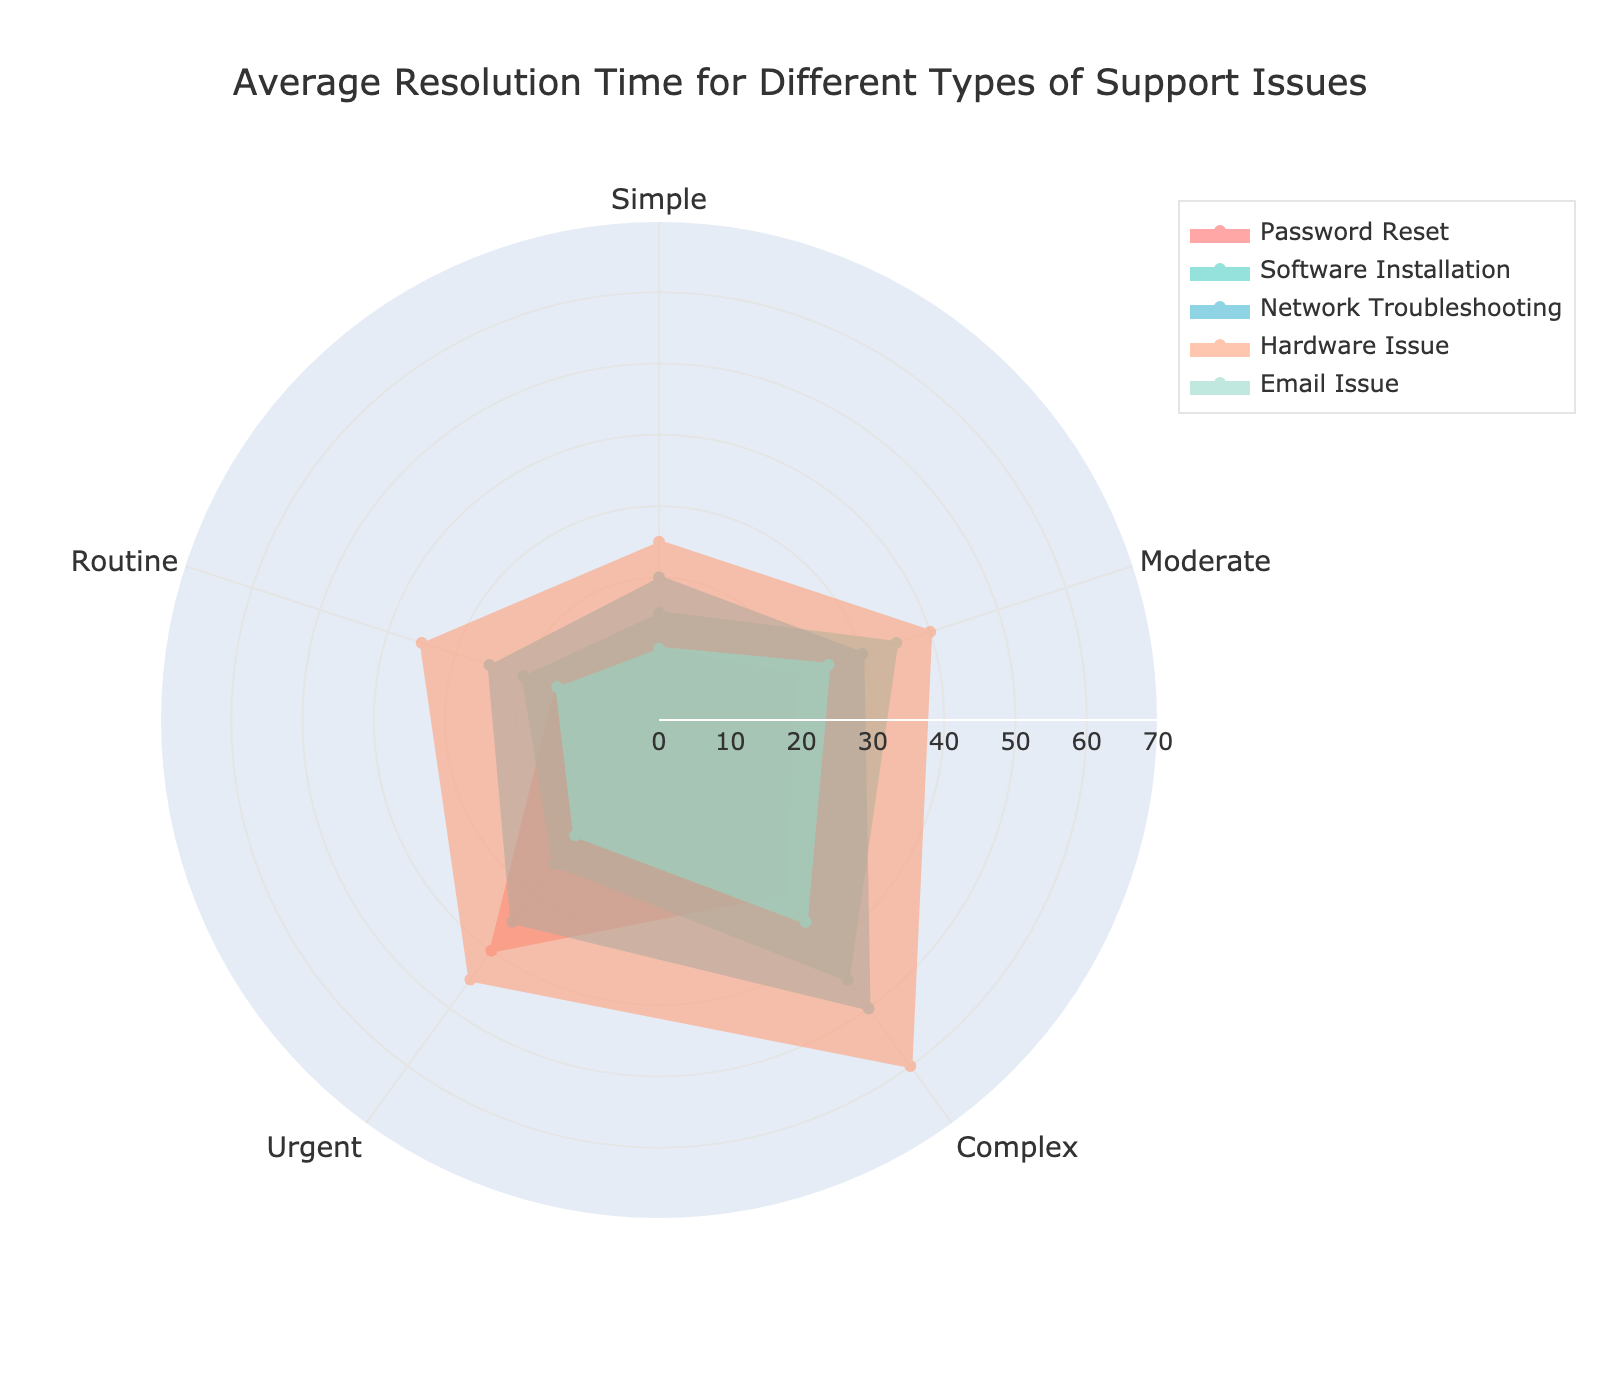What is the title of the radar chart? The title of the radar chart is usually at the top and indicates the general purpose of the chart. In this figure, the title is "Average Resolution Time for Different Types of Support Issues".
Answer: Average Resolution Time for Different Types of Support Issues How many types of support issues are represented in the chart? To determine the number of types, we look at the legend or the different traced lines. There are five lines, so there are five types of support issues.
Answer: Five Which type of support issue has the highest average resolution time for Complex issues? We identify the line that extends the farthest along the "Complex" axis. The "Hardware Issue" line reaches the highest value on this axis.
Answer: Hardware Issue What is the range of radial axis values for this radar chart? The radial axis values are specified in the layout setting of the chart, with the visible range going up to 70.
Answer: 0 to 70 What are the resolution times for "Password Reset" across all issue types? We look at the vertices of the "Password Reset" line corresponding to each type: Simple (10), Moderate (20), Complex (30), Urgent (40), and Routine (15).
Answer: 10, 20, 30, 40, 15 How does "Email Issue" resolution time compare between Simple and Urgent issues? By comparing the vertices on the "Email Issue" line for Simple (10) and Urgent (20) issues, we can see that Simple (10) is less than Urgent (20).
Answer: Simple is 10, Urgent is 20 Which issue type has the smallest average resolution time for "Network Troubleshooting"? Observing the "Network Troubleshooting" line, it reaches the smallest value at the Simple issue type.
Answer: Simple What's the average resolution time for "Software Installation" across all types? Adding the resolution times for "Software Installation" (15 + 35 + 45 + 25 + 20) and dividing by the number of types: (15 + 35 + 45 + 25 + 20) / 5 = 28.
Answer: 28 Which support issue type shows the most balanced resolution times across all types? To find the most balanced, we look for the line that is most evenly distributed among the axes. The "Email Issue" appears fairly balanced with values of 10, 25, 35, 20, 15.
Answer: Email Issue 